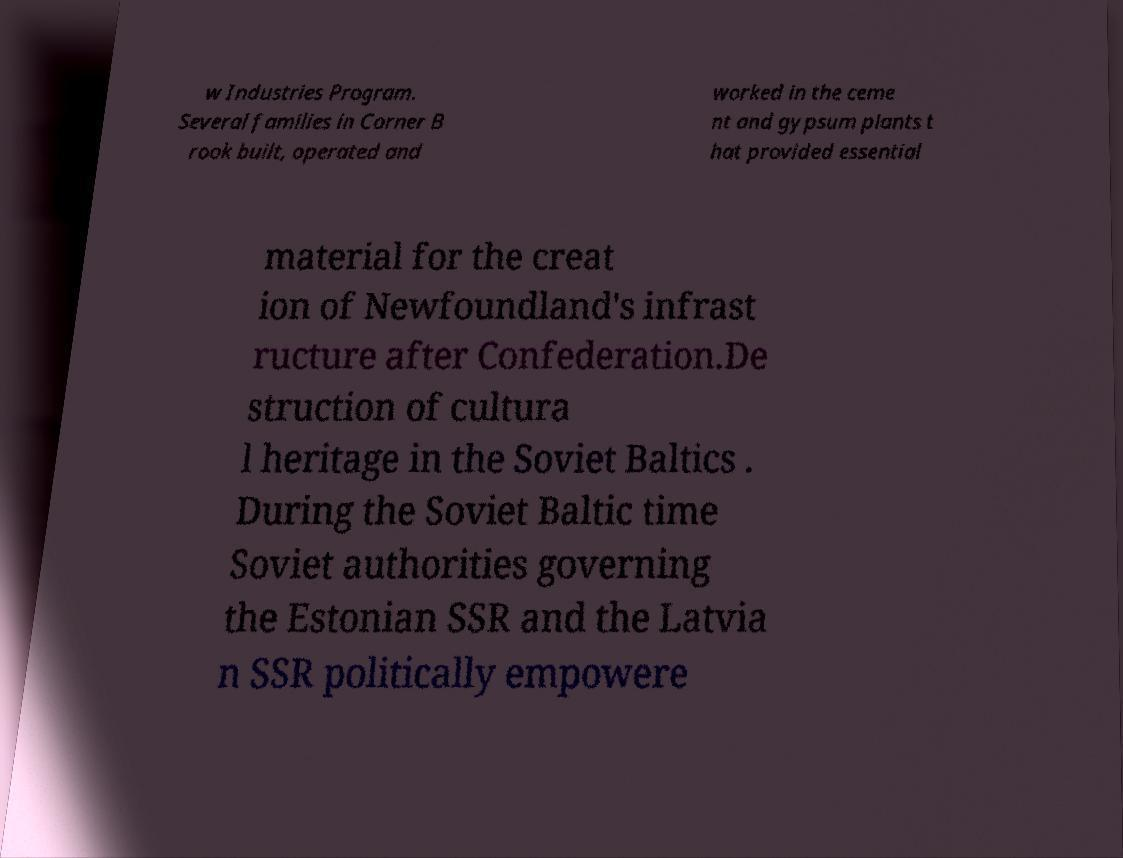There's text embedded in this image that I need extracted. Can you transcribe it verbatim? w Industries Program. Several families in Corner B rook built, operated and worked in the ceme nt and gypsum plants t hat provided essential material for the creat ion of Newfoundland's infrast ructure after Confederation.De struction of cultura l heritage in the Soviet Baltics . During the Soviet Baltic time Soviet authorities governing the Estonian SSR and the Latvia n SSR politically empowere 